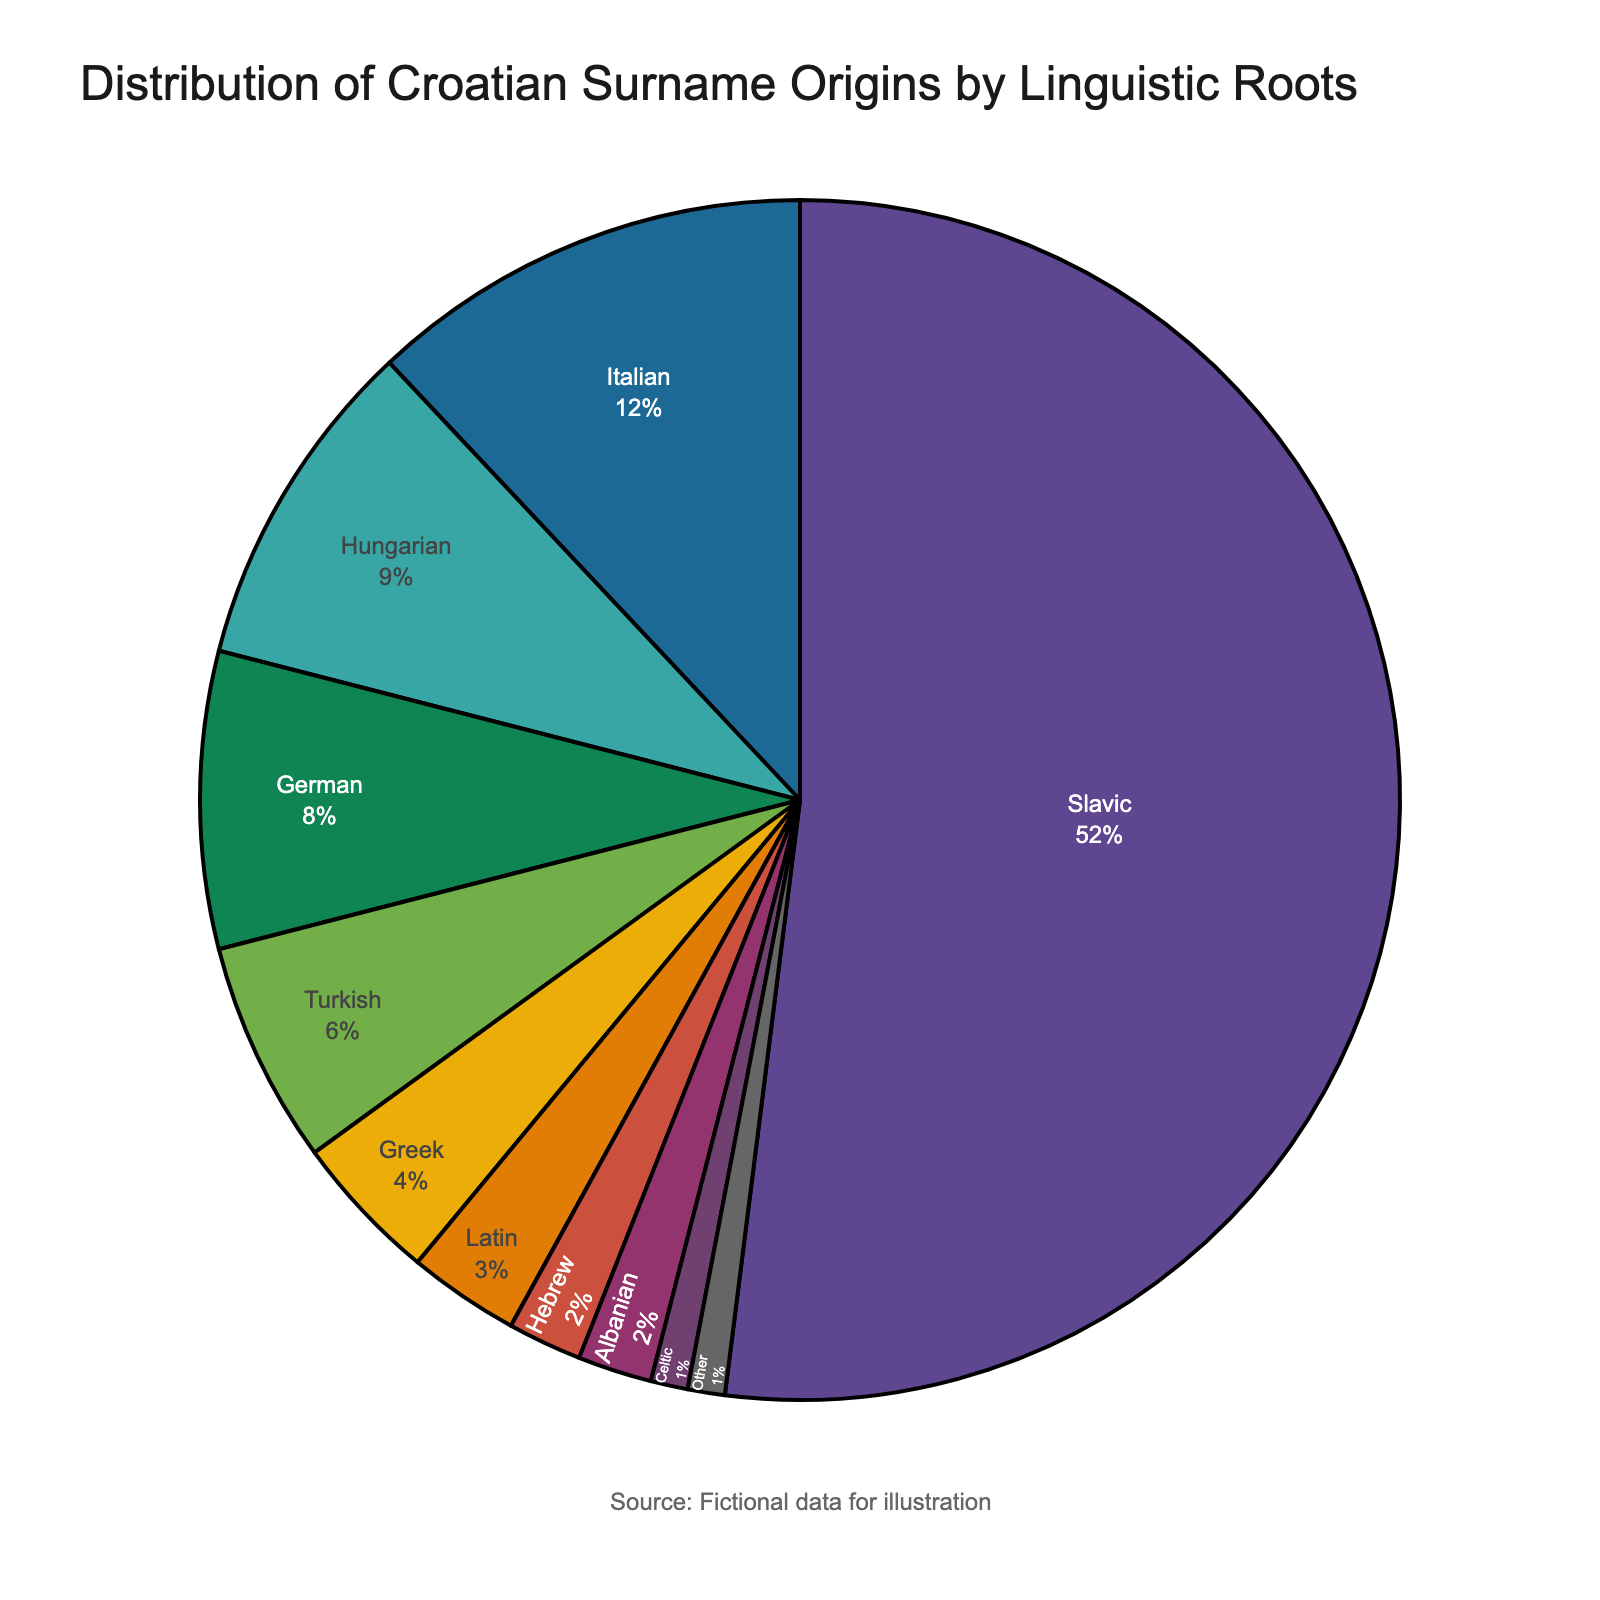What's the category with the highest percentage? The highest percentage segment is visually the largest one. According to the chart, "Slavic" occupies the largest portion.
Answer: Slavic What is the combined percentage of categories with origins from Hungary and Italy? From the chart, Hungarian has 9% and Italian has 12%. Adding these together gives 9% + 12% = 21%.
Answer: 21% Which categories have the smallest equal percentage, and what is that percentage? According to the pie chart, both Albanian and Celtic categories have the smallest percentage, and both are 1%.
Answer: Albanian and Celtic, 1% Is the percentage of German-origin surnames greater than Turkish-origin surnames? If so, by how much? The chart shows that German-origin surnames have 8% while Turkish-origin surnames have 6%. The difference is 8% - 6% = 2%.
Answer: Yes, by 2% What is the combined percentage of categories Slavic, Italian, and Hungarian? According to the pie chart, Slavic has 52%, Italian has 12%, and Hungarian has 9%. Adding these gives 52% + 12% + 9% = 73%.
Answer: 73% What percentage of surnames are from Greek and Latin origins combined compared to Slavic ones? Greek origins have 4% and Latin origins have 3%, combining to 4% + 3% = 7%. Compared to Slavic's 52%, 7% is far less.
Answer: 7% compared to 52% What is the difference in percentage between Hebrew-origin surnames and the “Other” category? Hebrew-origin surnames have 2%, and the "Other" category has 1%. The difference is 2% - 1% = 1%.
Answer: 1% Which category is more common: Latin or Turkish? By how much? Latin origins have 3%, while Turkish origins get 6%. Turkish is more common than Latin by 6% - 3% = 3%.
Answer: Turkish, by 3% Is there more Italian influence on Croatian surnames than Greek and Turkish combined? Italian has 12%, Greek has 4%, and Turkish has 6%. Combining Greek and Turkish gives 4% + 6% = 10%. Since Italian's 12% is greater than 10%, yes.
Answer: Yes What categories together make up exactly half of the distribution percentages? Slavic alone makes up 52%, which exceeds half. However, without Slavic, combining Italian (12%), Hungarian (9%), German (8%), and Turkish (6%) only totals 35%. Upon adding Greek (4%) and Latin (3%), reaching 42%. By including Hebrew (2%) and Albanian (2%), we get 46%. Adding Celtic (1%) and Other (1%), we achieve exactly 50%.
Answer: Italian, Hungarian, German, Turkish, Greek, Latin, Hebrew, Albanian, Celtic, Other 